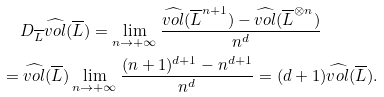<formula> <loc_0><loc_0><loc_500><loc_500>& \quad \, D _ { \overline { L } } \widehat { v o l } ( \overline { L } ) = \lim _ { n \rightarrow + \infty } \frac { \widehat { v o l } ( \overline { L } ^ { n + 1 } ) - \widehat { v o l } ( \overline { L } ^ { \otimes n } ) } { n ^ { d } } \\ & = \widehat { v o l } ( \overline { L } ) \lim _ { n \rightarrow + \infty } \frac { ( n + 1 ) ^ { d + 1 } - n ^ { d + 1 } } { n ^ { d } } = ( d + 1 ) \widehat { v o l } ( \overline { L } ) .</formula> 